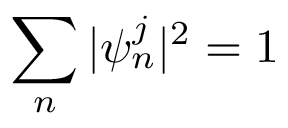<formula> <loc_0><loc_0><loc_500><loc_500>\sum _ { n } | \psi _ { n } ^ { j } | ^ { 2 } = 1</formula> 